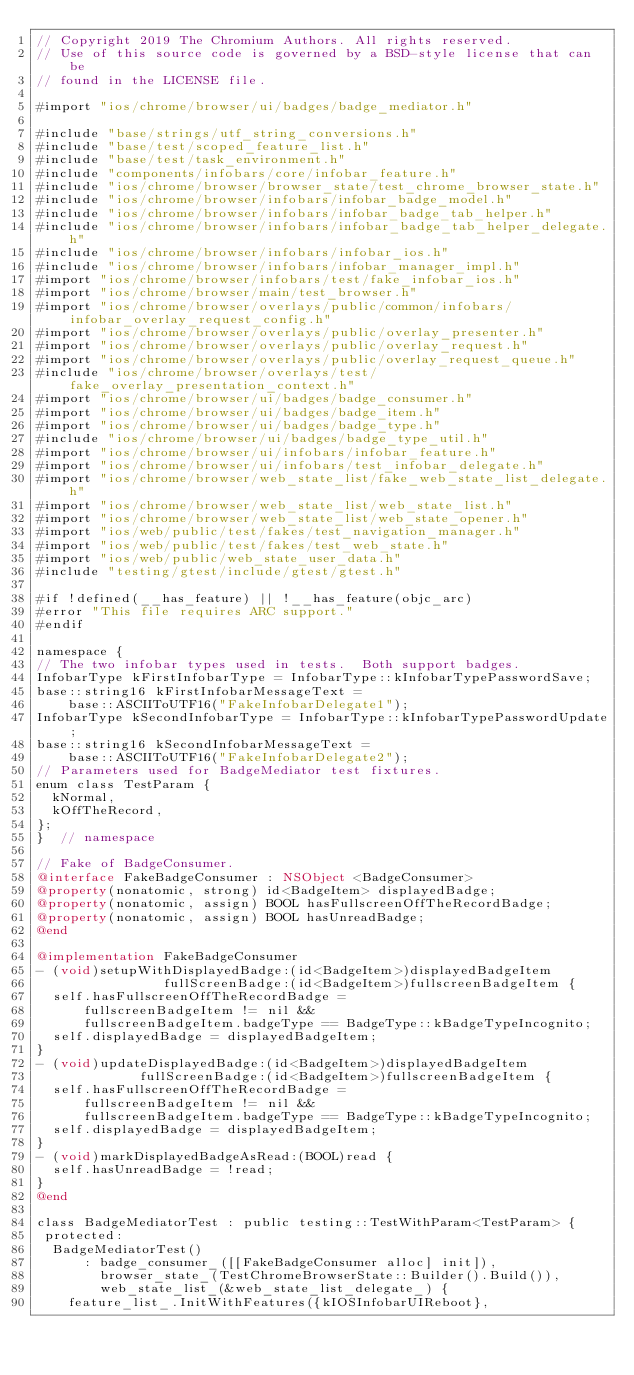<code> <loc_0><loc_0><loc_500><loc_500><_ObjectiveC_>// Copyright 2019 The Chromium Authors. All rights reserved.
// Use of this source code is governed by a BSD-style license that can be
// found in the LICENSE file.

#import "ios/chrome/browser/ui/badges/badge_mediator.h"

#include "base/strings/utf_string_conversions.h"
#include "base/test/scoped_feature_list.h"
#include "base/test/task_environment.h"
#include "components/infobars/core/infobar_feature.h"
#include "ios/chrome/browser/browser_state/test_chrome_browser_state.h"
#include "ios/chrome/browser/infobars/infobar_badge_model.h"
#include "ios/chrome/browser/infobars/infobar_badge_tab_helper.h"
#include "ios/chrome/browser/infobars/infobar_badge_tab_helper_delegate.h"
#include "ios/chrome/browser/infobars/infobar_ios.h"
#include "ios/chrome/browser/infobars/infobar_manager_impl.h"
#import "ios/chrome/browser/infobars/test/fake_infobar_ios.h"
#import "ios/chrome/browser/main/test_browser.h"
#import "ios/chrome/browser/overlays/public/common/infobars/infobar_overlay_request_config.h"
#import "ios/chrome/browser/overlays/public/overlay_presenter.h"
#import "ios/chrome/browser/overlays/public/overlay_request.h"
#import "ios/chrome/browser/overlays/public/overlay_request_queue.h"
#include "ios/chrome/browser/overlays/test/fake_overlay_presentation_context.h"
#import "ios/chrome/browser/ui/badges/badge_consumer.h"
#import "ios/chrome/browser/ui/badges/badge_item.h"
#import "ios/chrome/browser/ui/badges/badge_type.h"
#include "ios/chrome/browser/ui/badges/badge_type_util.h"
#import "ios/chrome/browser/ui/infobars/infobar_feature.h"
#import "ios/chrome/browser/ui/infobars/test_infobar_delegate.h"
#import "ios/chrome/browser/web_state_list/fake_web_state_list_delegate.h"
#import "ios/chrome/browser/web_state_list/web_state_list.h"
#import "ios/chrome/browser/web_state_list/web_state_opener.h"
#import "ios/web/public/test/fakes/test_navigation_manager.h"
#import "ios/web/public/test/fakes/test_web_state.h"
#import "ios/web/public/web_state_user_data.h"
#include "testing/gtest/include/gtest/gtest.h"

#if !defined(__has_feature) || !__has_feature(objc_arc)
#error "This file requires ARC support."
#endif

namespace {
// The two infobar types used in tests.  Both support badges.
InfobarType kFirstInfobarType = InfobarType::kInfobarTypePasswordSave;
base::string16 kFirstInfobarMessageText =
    base::ASCIIToUTF16("FakeInfobarDelegate1");
InfobarType kSecondInfobarType = InfobarType::kInfobarTypePasswordUpdate;
base::string16 kSecondInfobarMessageText =
    base::ASCIIToUTF16("FakeInfobarDelegate2");
// Parameters used for BadgeMediator test fixtures.
enum class TestParam {
  kNormal,
  kOffTheRecord,
};
}  // namespace

// Fake of BadgeConsumer.
@interface FakeBadgeConsumer : NSObject <BadgeConsumer>
@property(nonatomic, strong) id<BadgeItem> displayedBadge;
@property(nonatomic, assign) BOOL hasFullscreenOffTheRecordBadge;
@property(nonatomic, assign) BOOL hasUnreadBadge;
@end

@implementation FakeBadgeConsumer
- (void)setupWithDisplayedBadge:(id<BadgeItem>)displayedBadgeItem
                fullScreenBadge:(id<BadgeItem>)fullscreenBadgeItem {
  self.hasFullscreenOffTheRecordBadge =
      fullscreenBadgeItem != nil &&
      fullscreenBadgeItem.badgeType == BadgeType::kBadgeTypeIncognito;
  self.displayedBadge = displayedBadgeItem;
}
- (void)updateDisplayedBadge:(id<BadgeItem>)displayedBadgeItem
             fullScreenBadge:(id<BadgeItem>)fullscreenBadgeItem {
  self.hasFullscreenOffTheRecordBadge =
      fullscreenBadgeItem != nil &&
      fullscreenBadgeItem.badgeType == BadgeType::kBadgeTypeIncognito;
  self.displayedBadge = displayedBadgeItem;
}
- (void)markDisplayedBadgeAsRead:(BOOL)read {
  self.hasUnreadBadge = !read;
}
@end

class BadgeMediatorTest : public testing::TestWithParam<TestParam> {
 protected:
  BadgeMediatorTest()
      : badge_consumer_([[FakeBadgeConsumer alloc] init]),
        browser_state_(TestChromeBrowserState::Builder().Build()),
        web_state_list_(&web_state_list_delegate_) {
    feature_list_.InitWithFeatures({kIOSInfobarUIReboot},</code> 